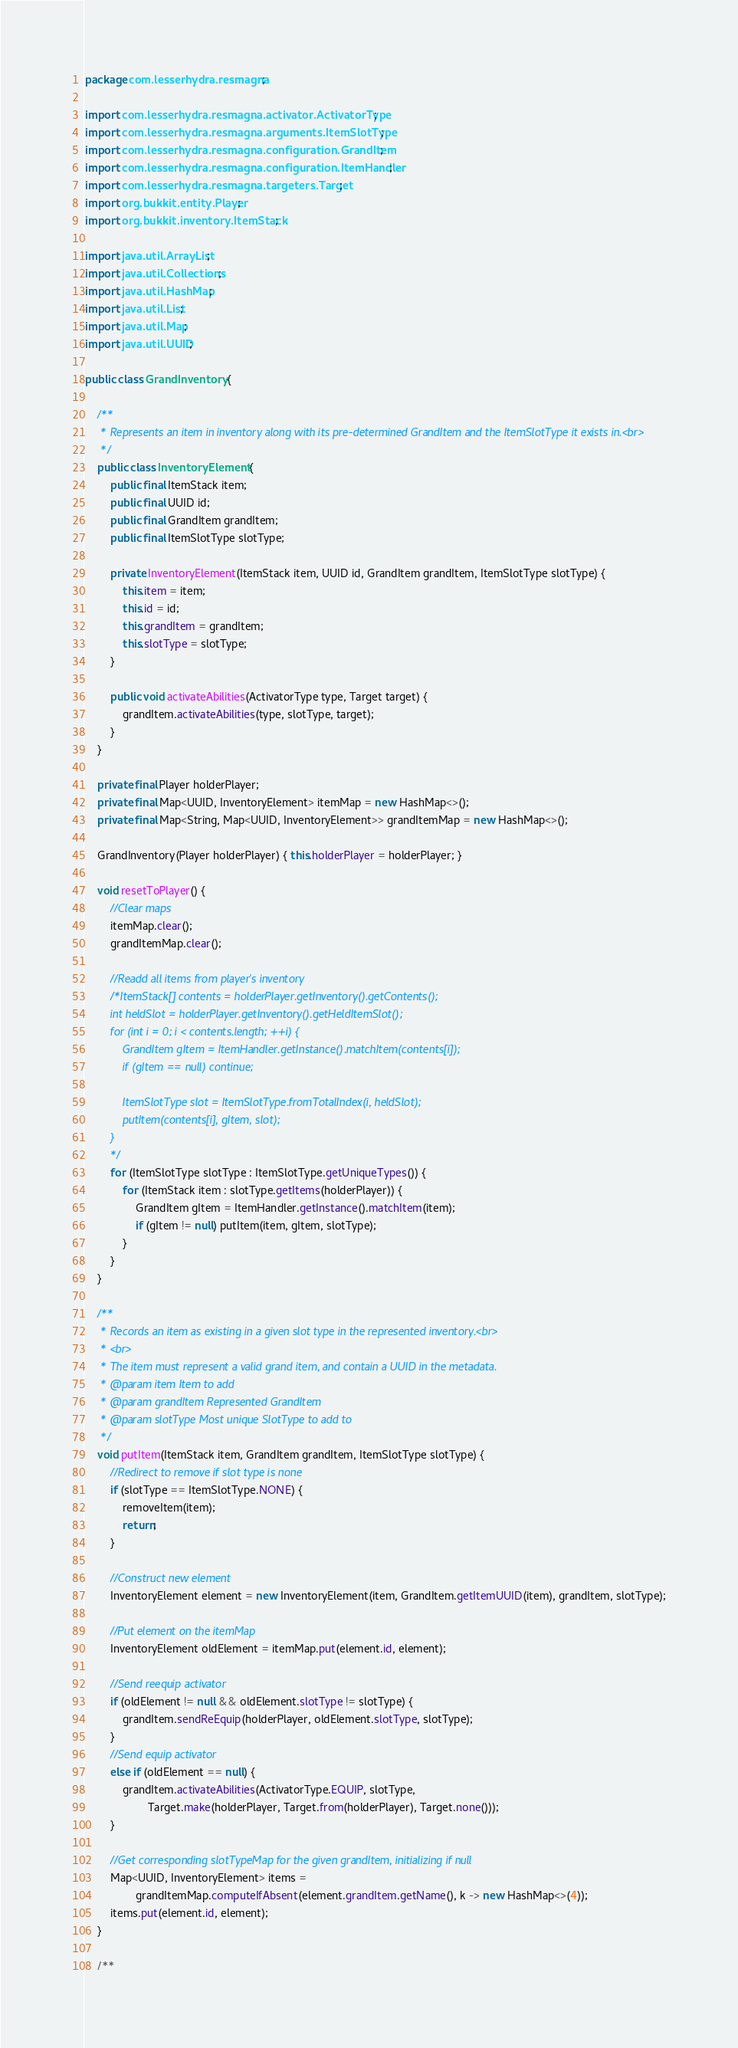<code> <loc_0><loc_0><loc_500><loc_500><_Java_>package com.lesserhydra.resmagna;

import com.lesserhydra.resmagna.activator.ActivatorType;
import com.lesserhydra.resmagna.arguments.ItemSlotType;
import com.lesserhydra.resmagna.configuration.GrandItem;
import com.lesserhydra.resmagna.configuration.ItemHandler;
import com.lesserhydra.resmagna.targeters.Target;
import org.bukkit.entity.Player;
import org.bukkit.inventory.ItemStack;

import java.util.ArrayList;
import java.util.Collections;
import java.util.HashMap;
import java.util.List;
import java.util.Map;
import java.util.UUID;

public class GrandInventory {
	
	/**
	 * Represents an item in inventory along with its pre-determined GrandItem and the ItemSlotType it exists in.<br>
	 */
	public class InventoryElement {
		public final ItemStack item;
		public final UUID id;
		public final GrandItem grandItem;
		public final ItemSlotType slotType;
		
		private InventoryElement(ItemStack item, UUID id, GrandItem grandItem, ItemSlotType slotType) {
			this.item = item;
			this.id = id;
			this.grandItem = grandItem;
			this.slotType = slotType;
		}
		
		public void activateAbilities(ActivatorType type, Target target) {
			grandItem.activateAbilities(type, slotType, target);
		}
	}
	
	private final Player holderPlayer;
	private final Map<UUID, InventoryElement> itemMap = new HashMap<>();
	private final Map<String, Map<UUID, InventoryElement>> grandItemMap = new HashMap<>();
	
	GrandInventory(Player holderPlayer) { this.holderPlayer = holderPlayer; }
	
	void resetToPlayer() {
		//Clear maps
		itemMap.clear();
		grandItemMap.clear();
		
		//Readd all items from player's inventory
		/*ItemStack[] contents = holderPlayer.getInventory().getContents();
		int heldSlot = holderPlayer.getInventory().getHeldItemSlot();
		for (int i = 0; i < contents.length; ++i) {
			GrandItem gItem = ItemHandler.getInstance().matchItem(contents[i]);
			if (gItem == null) continue;
			
			ItemSlotType slot = ItemSlotType.fromTotalIndex(i, heldSlot);
			putItem(contents[i], gItem, slot);
		}
		*/
		for (ItemSlotType slotType : ItemSlotType.getUniqueTypes()) {
			for (ItemStack item : slotType.getItems(holderPlayer)) {
				GrandItem gItem = ItemHandler.getInstance().matchItem(item);
				if (gItem != null) putItem(item, gItem, slotType);
			}
		}
	}
	
	/**
	 * Records an item as existing in a given slot type in the represented inventory.<br>
	 * <br>
	 * The item must represent a valid grand item, and contain a UUID in the metadata.
	 * @param item Item to add
	 * @param grandItem Represented GrandItem
	 * @param slotType Most unique SlotType to add to
	 */
	void putItem(ItemStack item, GrandItem grandItem, ItemSlotType slotType) {
		//Redirect to remove if slot type is none
		if (slotType == ItemSlotType.NONE) {
			removeItem(item);
			return;
		}
		
		//Construct new element
		InventoryElement element = new InventoryElement(item, GrandItem.getItemUUID(item), grandItem, slotType);
		
		//Put element on the itemMap
		InventoryElement oldElement = itemMap.put(element.id, element);
		
		//Send reequip activator
		if (oldElement != null && oldElement.slotType != slotType) {
			grandItem.sendReEquip(holderPlayer, oldElement.slotType, slotType);
		}
		//Send equip activator
		else if (oldElement == null) {
			grandItem.activateAbilities(ActivatorType.EQUIP, slotType,
					Target.make(holderPlayer, Target.from(holderPlayer), Target.none()));
		}
		
		//Get corresponding slotTypeMap for the given grandItem, initializing if null
		Map<UUID, InventoryElement> items =
				grandItemMap.computeIfAbsent(element.grandItem.getName(), k -> new HashMap<>(4));
		items.put(element.id, element);
	}
	
	/**</code> 